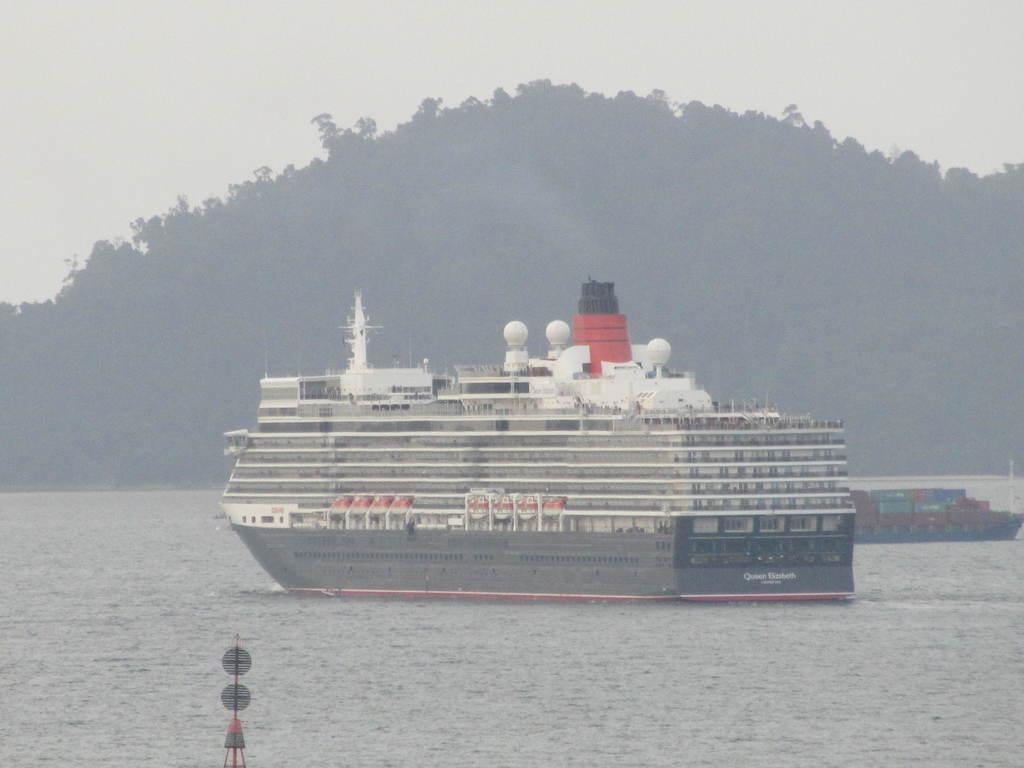Please provide a concise description of this image. This picture shows a ship and boat in the water and we see trees and a cloudy sky. 